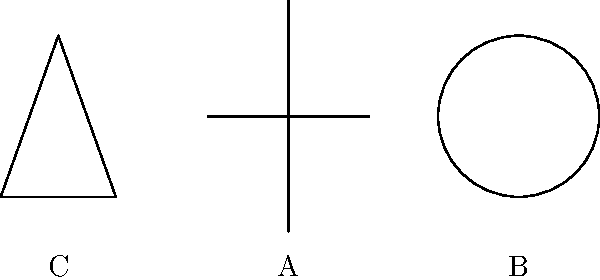In the image above, three common religious symbols are represented by basic geometric shapes. Which of these symbols (A, B, or C) is most commonly associated with Christianity and why? Let's analyze each symbol:

1. Symbol A: This is a cross, formed by two intersecting lines. The cross is the primary symbol of Christianity, representing the crucifixion of Jesus Christ.

2. Symbol B: This is a circle, which is often associated with concepts of eternity or wholeness in various religions. In some contexts, it might represent the Buddhist wheel of dharma or a mandala.

3. Symbol C: This is a triangle, which can symbolize the Christian concept of the Holy Trinity (Father, Son, and Holy Spirit) but is not as universally recognized as the primary symbol of Christianity.

The cross (Symbol A) is the most widely recognized and used symbol in Christianity for several reasons:

1. Historical significance: It directly represents the method of Jesus Christ's execution, which is central to Christian theology.
2. Theological meaning: It symbolizes Christ's sacrifice and the concept of salvation through His death and resurrection.
3. Universality: The cross is used across virtually all Christian denominations and traditions.
4. Simplicity: Its basic shape makes it easy to reproduce and recognize.

While the triangle can have Christian significance, and the circle has various religious meanings, neither is as closely or universally associated with Christianity as the cross.

Therefore, Symbol A (the cross) is most commonly associated with Christianity due to its direct connection to the faith's central figure and message.
Answer: A (Cross) 